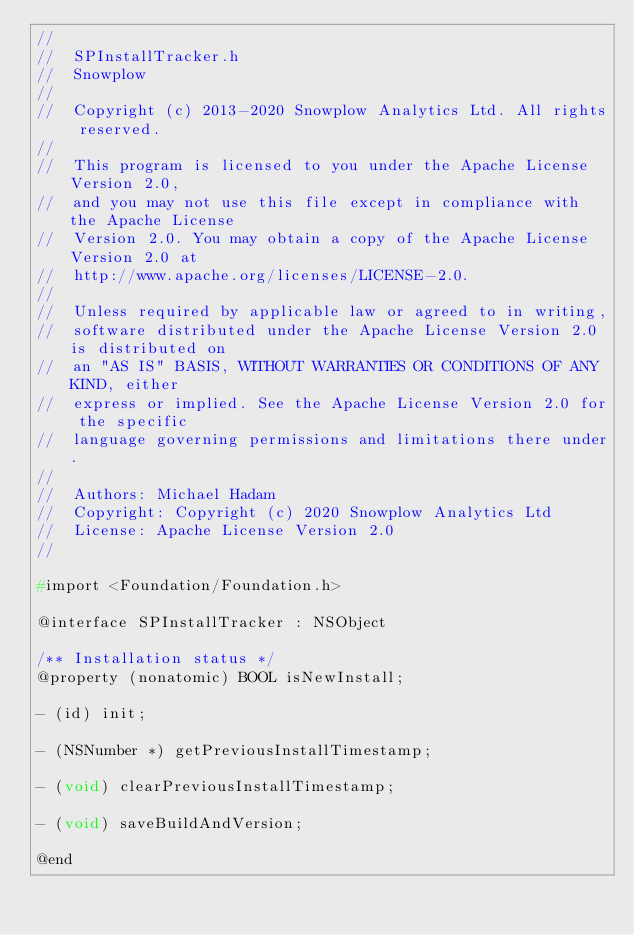Convert code to text. <code><loc_0><loc_0><loc_500><loc_500><_C_>//
//  SPInstallTracker.h
//  Snowplow
//
//  Copyright (c) 2013-2020 Snowplow Analytics Ltd. All rights reserved.
//
//  This program is licensed to you under the Apache License Version 2.0,
//  and you may not use this file except in compliance with the Apache License
//  Version 2.0. You may obtain a copy of the Apache License Version 2.0 at
//  http://www.apache.org/licenses/LICENSE-2.0.
//
//  Unless required by applicable law or agreed to in writing,
//  software distributed under the Apache License Version 2.0 is distributed on
//  an "AS IS" BASIS, WITHOUT WARRANTIES OR CONDITIONS OF ANY KIND, either
//  express or implied. See the Apache License Version 2.0 for the specific
//  language governing permissions and limitations there under.
//
//  Authors: Michael Hadam
//  Copyright: Copyright (c) 2020 Snowplow Analytics Ltd
//  License: Apache License Version 2.0
//

#import <Foundation/Foundation.h>

@interface SPInstallTracker : NSObject

/** Installation status */
@property (nonatomic) BOOL isNewInstall;

- (id) init;

- (NSNumber *) getPreviousInstallTimestamp;

- (void) clearPreviousInstallTimestamp;

- (void) saveBuildAndVersion;

@end
</code> 